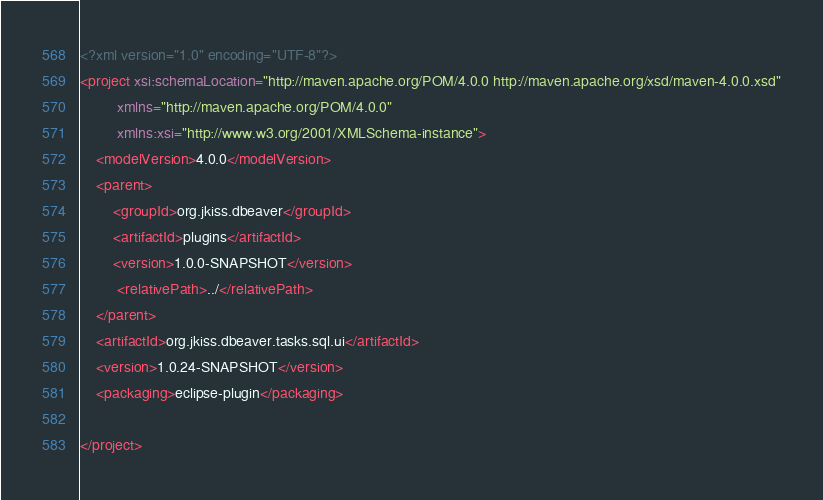<code> <loc_0><loc_0><loc_500><loc_500><_XML_><?xml version="1.0" encoding="UTF-8"?>
<project xsi:schemaLocation="http://maven.apache.org/POM/4.0.0 http://maven.apache.org/xsd/maven-4.0.0.xsd"
         xmlns="http://maven.apache.org/POM/4.0.0"
         xmlns:xsi="http://www.w3.org/2001/XMLSchema-instance">
    <modelVersion>4.0.0</modelVersion>
    <parent>
        <groupId>org.jkiss.dbeaver</groupId>
        <artifactId>plugins</artifactId>
        <version>1.0.0-SNAPSHOT</version>
         <relativePath>../</relativePath>
    </parent>
    <artifactId>org.jkiss.dbeaver.tasks.sql.ui</artifactId>
    <version>1.0.24-SNAPSHOT</version>
    <packaging>eclipse-plugin</packaging>

</project>
</code> 